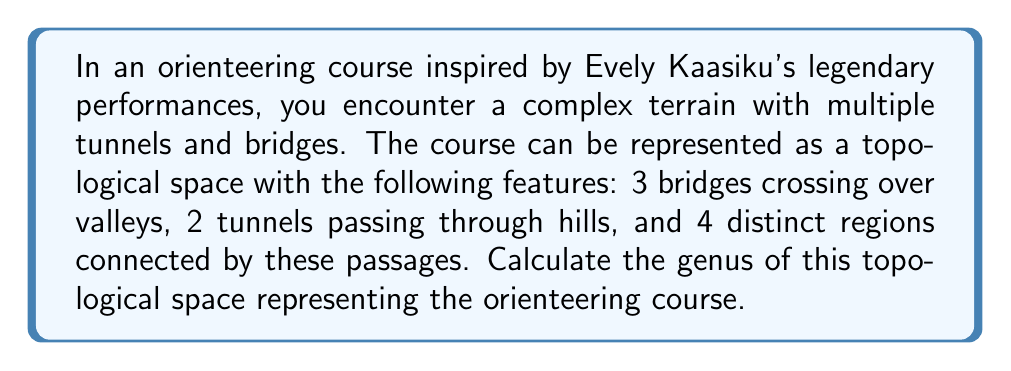Can you answer this question? To calculate the genus of this topological space, we'll use the Euler characteristic formula and the relationship between Euler characteristic and genus for a connected, orientable surface.

1. First, let's identify the components of our topological space:
   - Vertices (V): 4 (the distinct regions)
   - Edges (E): 5 (3 bridges + 2 tunnels)
   - Faces (F): 1 (the exterior face)

2. Calculate the Euler characteristic (χ):
   $$χ = V - E + F$$
   $$χ = 4 - 5 + 1 = 0$$

3. For a connected, orientable surface, the relationship between Euler characteristic (χ) and genus (g) is given by:
   $$χ = 2 - 2g$$

4. Solve for g:
   $$0 = 2 - 2g$$
   $$2g = 2$$
   $$g = 1$$

The genus of 1 indicates that our orienteering course topologically equivalent to a torus (a donut shape). This makes sense given the presence of bridges and tunnels, which create "holes" in the surface, similar to the hole in a torus.
Answer: The genus of the topological space representing the orienteering course is 1. 